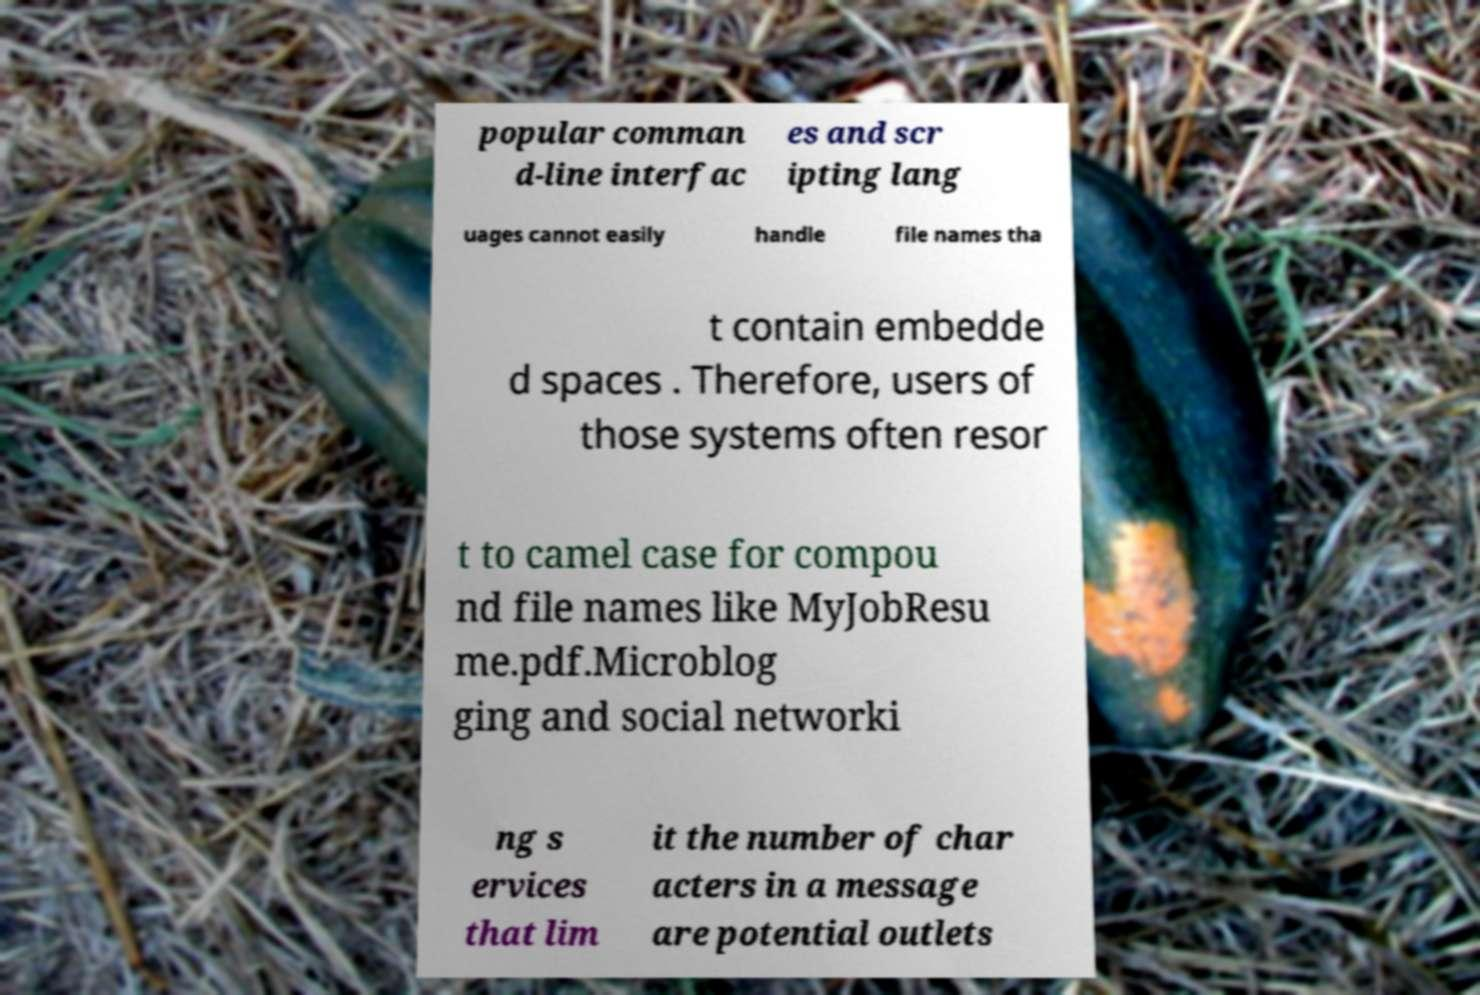Could you assist in decoding the text presented in this image and type it out clearly? popular comman d-line interfac es and scr ipting lang uages cannot easily handle file names tha t contain embedde d spaces . Therefore, users of those systems often resor t to camel case for compou nd file names like MyJobResu me.pdf.Microblog ging and social networki ng s ervices that lim it the number of char acters in a message are potential outlets 